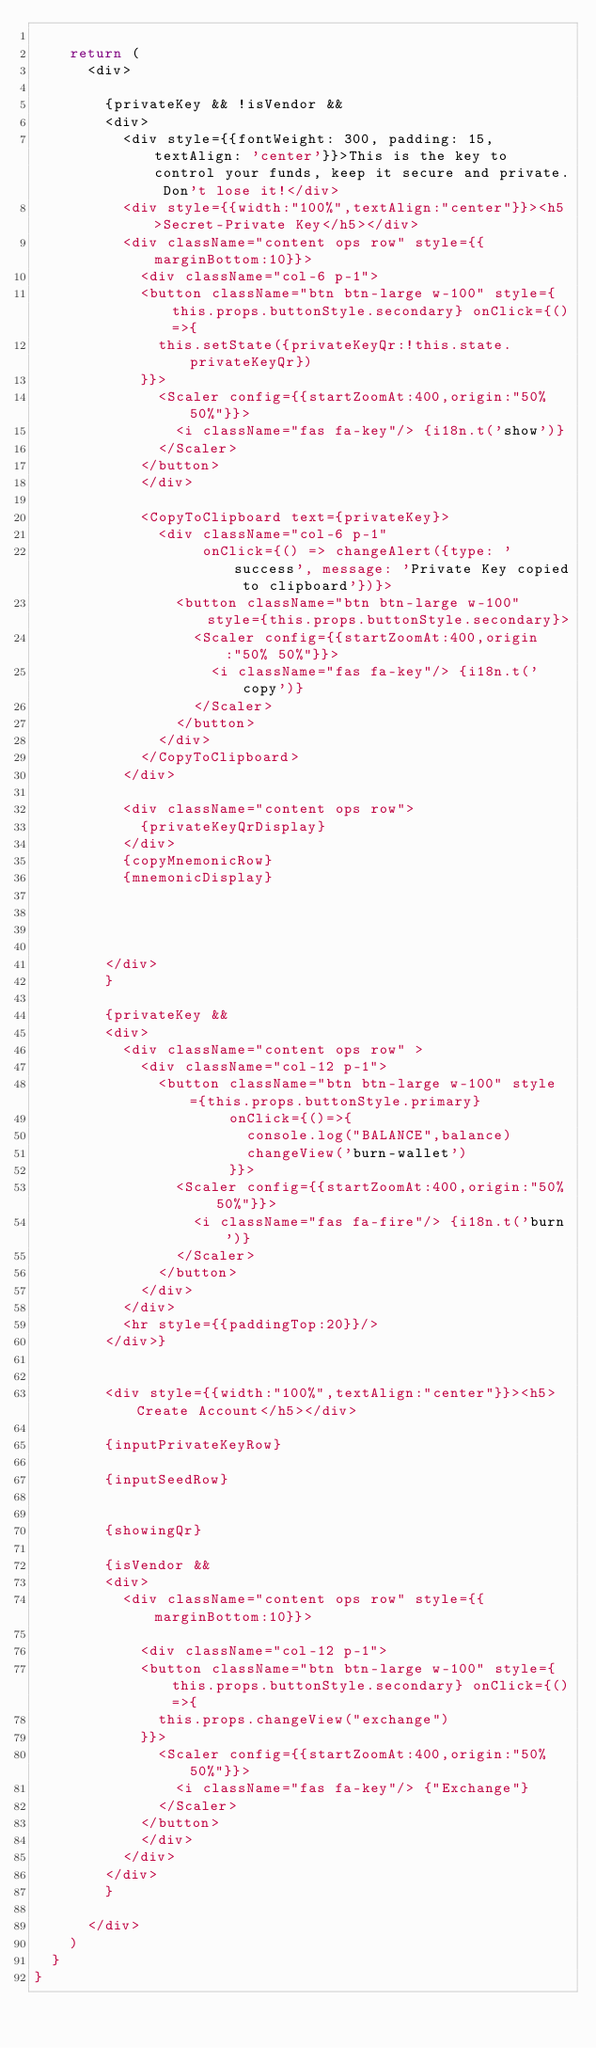Convert code to text. <code><loc_0><loc_0><loc_500><loc_500><_JavaScript_>
    return (
      <div>

        {privateKey && !isVendor &&
        <div>
          <div style={{fontWeight: 300, padding: 15, textAlign: 'center'}}>This is the key to control your funds, keep it secure and private. Don't lose it!</div>
          <div style={{width:"100%",textAlign:"center"}}><h5>Secret-Private Key</h5></div>
          <div className="content ops row" style={{marginBottom:10}}>
            <div className="col-6 p-1">
            <button className="btn btn-large w-100" style={this.props.buttonStyle.secondary} onClick={()=>{
              this.setState({privateKeyQr:!this.state.privateKeyQr})
            }}>
              <Scaler config={{startZoomAt:400,origin:"50% 50%"}}>
                <i className="fas fa-key"/> {i18n.t('show')}
              </Scaler>
            </button>
            </div>

            <CopyToClipboard text={privateKey}>
              <div className="col-6 p-1"
                   onClick={() => changeAlert({type: 'success', message: 'Private Key copied to clipboard'})}>
                <button className="btn btn-large w-100" style={this.props.buttonStyle.secondary}>
                  <Scaler config={{startZoomAt:400,origin:"50% 50%"}}>
                    <i className="fas fa-key"/> {i18n.t('copy')}
                  </Scaler>
                </button>
              </div>
            </CopyToClipboard>
          </div>
          
          <div className="content ops row">
            {privateKeyQrDisplay}
          </div>
          {copyMnemonicRow}
          {mnemonicDisplay}


          

        </div>
        }

        {privateKey &&
        <div>
          <div className="content ops row" >
            <div className="col-12 p-1">
              <button className="btn btn-large w-100" style={this.props.buttonStyle.primary}
                      onClick={()=>{
                        console.log("BALANCE",balance)
                        changeView('burn-wallet')
                      }}>
                <Scaler config={{startZoomAt:400,origin:"50% 50%"}}>
                  <i className="fas fa-fire"/> {i18n.t('burn')}
                </Scaler>
              </button>
            </div>
          </div>
          <hr style={{paddingTop:20}}/>
        </div>}


        <div style={{width:"100%",textAlign:"center"}}><h5>Create Account</h5></div>

        {inputPrivateKeyRow}

        {inputSeedRow}


        {showingQr}

        {isVendor &&
        <div>
          <div className="content ops row" style={{marginBottom:10}}>

            <div className="col-12 p-1">
            <button className="btn btn-large w-100" style={this.props.buttonStyle.secondary} onClick={()=>{
              this.props.changeView("exchange")
            }}>
              <Scaler config={{startZoomAt:400,origin:"50% 50%"}}>
                <i className="fas fa-key"/> {"Exchange"}
              </Scaler>
            </button>
            </div>
          </div>
        </div>
        }

      </div>
    )
  }
}
</code> 